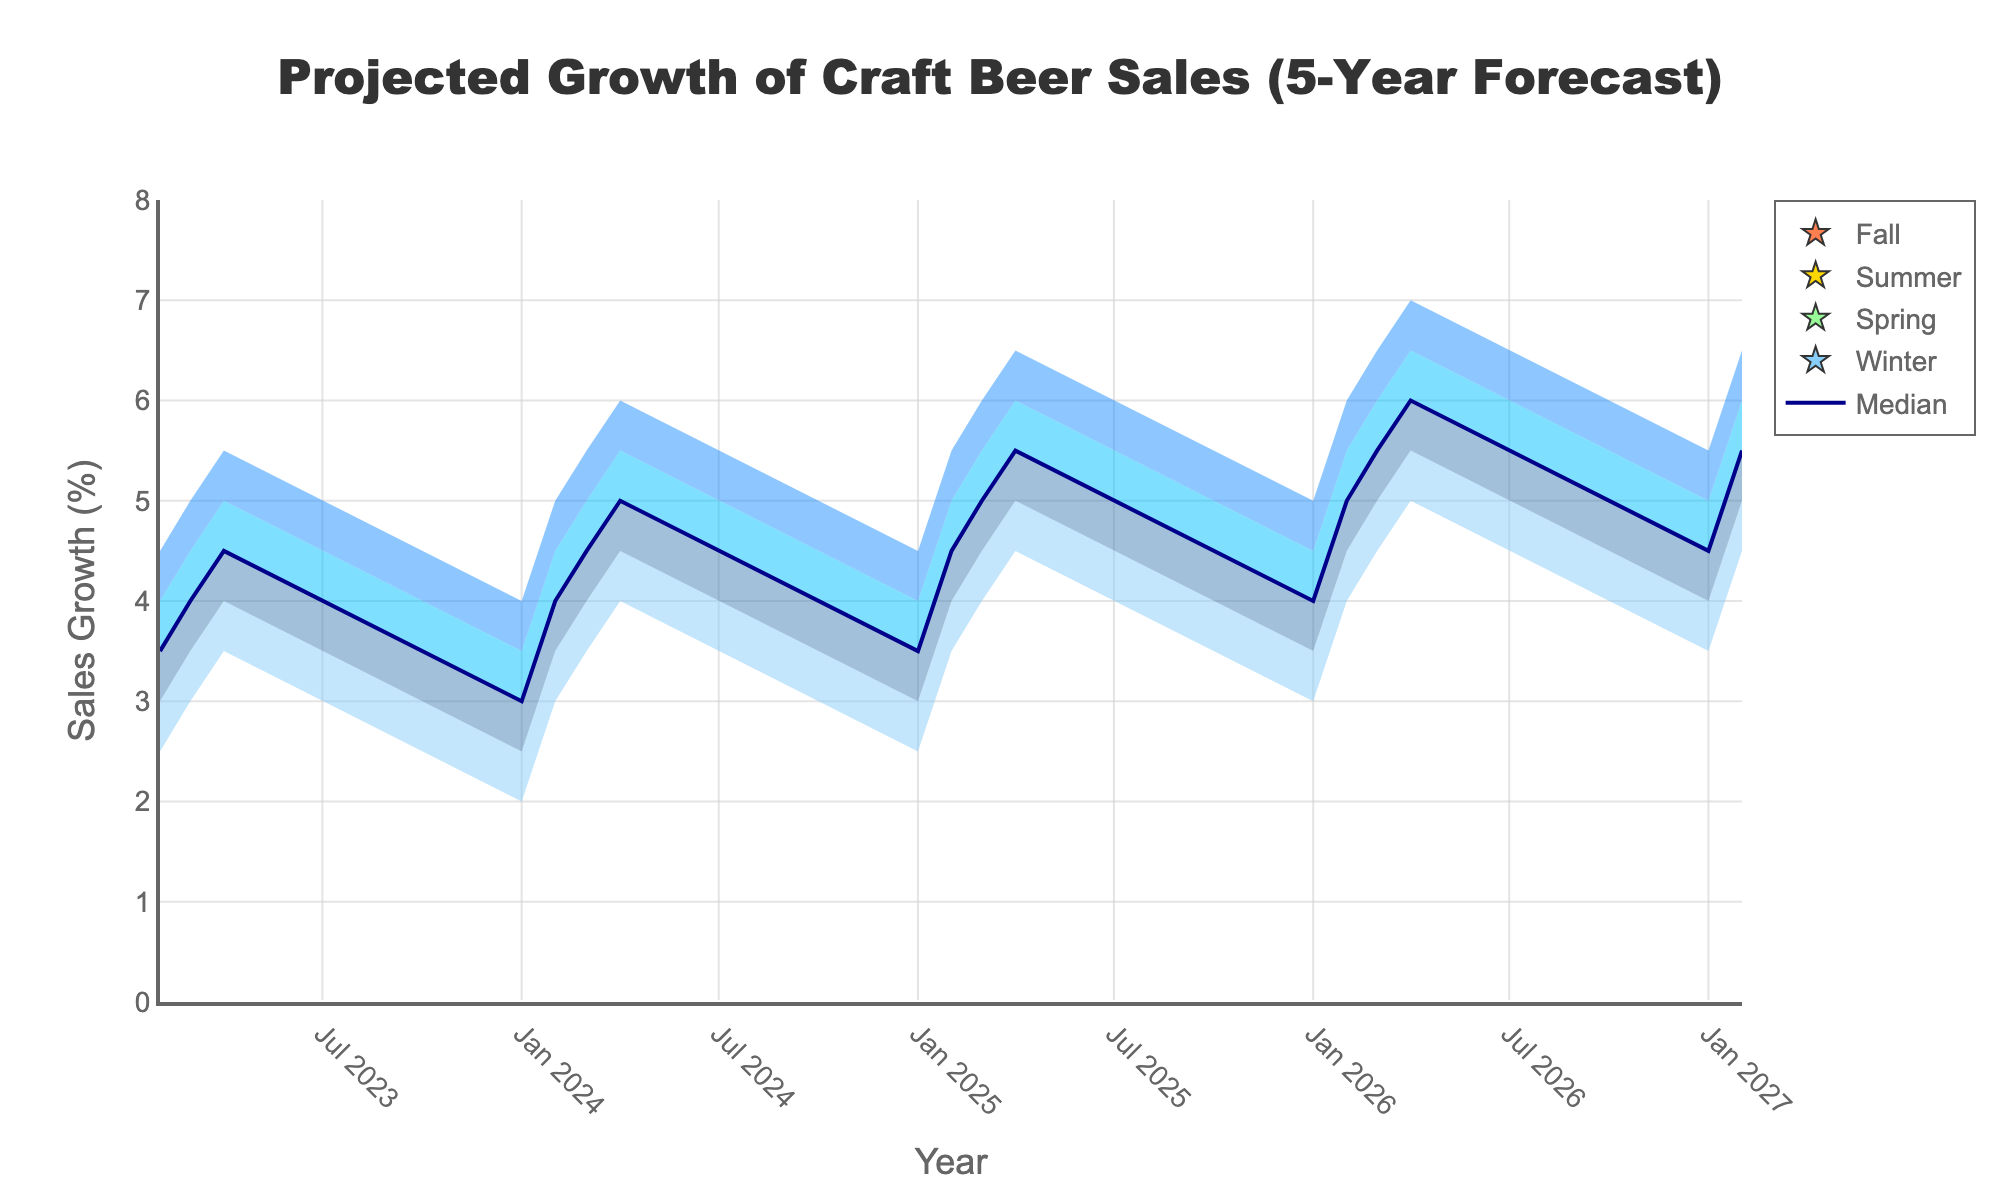What's the title of the chart? The title of the chart is located at the top and it usually summarizes the main subject of the plot. In this case, it states: "Projected Growth of Craft Beer Sales (5-Year Forecast)"
Answer: Projected Growth of Craft Beer Sales (5-Year Forecast) Which quarter and year are projected to have the highest median sales growth? By examining the median line closely, the peak median sales growth is visually represented. The highest point of the median line occurs at the end of 2026 Q4.
Answer: 2026 Q4 How does the sales growth in 2024 Q1 compare to 2023 Q2 in terms of the median value? We need to observe the positioning of the median values for 2024 Q1 and 2023 Q2. In 2024 Q1, the median is at 3.0, whereas in 2023 Q2, it is at 3.5. Hence, the median sales growth in 2024 Q1 is lower than in 2023 Q2.
Answer: 2024 Q1 is lower During which seasons do the high projections consistently peak in every year, based on the given data? We can identify the seasons by the quarterly data representation. When looking at 'Q3' for each year, we find that the high sales growth projections are consistently higher in the summer months (Q3) compared to other seasons.
Answer: Summer (Q3) What is the projected range for sales growth in 2026 Q2 from the lowest to the highest value? The data provides the specific projections for each quarter. For 2026 Q2, the lowest projection is 4.0 and the highest is 6.0, therefore the range is from 4.0 to 6.0.
Answer: 4.0 to 6.0 If the actual sales growth in 2025 Q3 falls within the mid-high percentile range, what would be the expected range of values? The mid-high percentile is a part of the fan chart, representing one of the shaded areas between the median and high projections. In 2025 Q3, this range is from 5.5 to 6.0.
Answer: 5.5 to 6.0 What trend do we observe in the seasonality of sales growth from winter to fall each year? By looking at the seasonal markers and visualizing the four seasons, we can see that sales growth tends to dip in winter (Q1), rise through spring (Q2), peak in summer (Q3), and remain relatively high in fall (Q4).
Answer: Sales dip in winter and peak in summer What is the difference between the low projection and the high projection for 2027 Q1? Referring to the projections for 2027 Q1, the low projection is 3.5 and the high projection is 5.5. The difference between these values can be calculated as 5.5 - 3.5, totaling 2.0.
Answer: 2.0 What year and quarter is the lowest median projection observed? By examining the median projections over the five years, the lowest median value can be detected. It is in 2024 Q1 with a median value of 3.0
Answer: 2024 Q1 